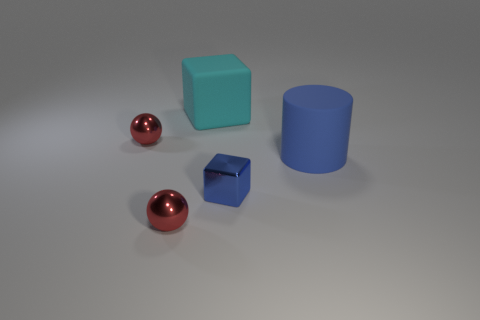What number of matte things are blue cylinders or tiny gray cylinders?
Ensure brevity in your answer.  1. There is a tiny shiny thing that is behind the big rubber thing that is in front of the large matte cube; is there a large cyan matte cube right of it?
Make the answer very short. Yes. The cyan cube that is made of the same material as the big cylinder is what size?
Your answer should be compact. Large. There is a large blue object; are there any large blue things left of it?
Provide a short and direct response. No. There is a small red sphere that is in front of the blue cube; is there a small red sphere in front of it?
Your response must be concise. No. There is a blue thing behind the tiny cube; does it have the same size as the block in front of the cylinder?
Your answer should be compact. No. How many small things are either green blocks or blue cylinders?
Make the answer very short. 0. What material is the thing that is to the right of the blue metallic block in front of the large cyan block?
Provide a succinct answer. Rubber. What is the shape of the object that is the same color as the matte cylinder?
Ensure brevity in your answer.  Cube. Is there a green cylinder made of the same material as the blue cube?
Provide a short and direct response. No. 